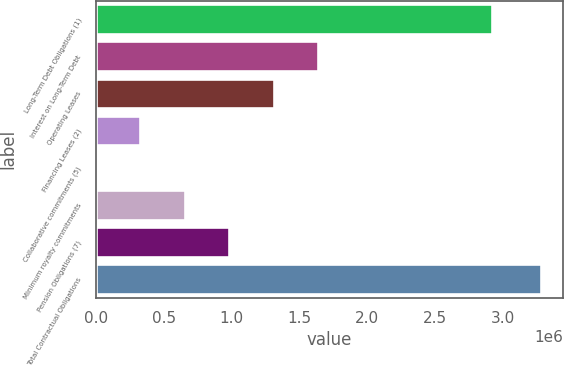Convert chart to OTSL. <chart><loc_0><loc_0><loc_500><loc_500><bar_chart><fcel>Long-Term Debt Obligations (1)<fcel>Interest on Long-Term Debt<fcel>Operating Leases<fcel>Financing Leases (2)<fcel>Collaborative commitments (5)<fcel>Minimum royalty commitments<fcel>Pension Obligations (7)<fcel>Total Contractual Obligations<nl><fcel>2.925e+06<fcel>1.64172e+06<fcel>1.31338e+06<fcel>328352<fcel>10<fcel>656694<fcel>985035<fcel>3.28343e+06<nl></chart> 